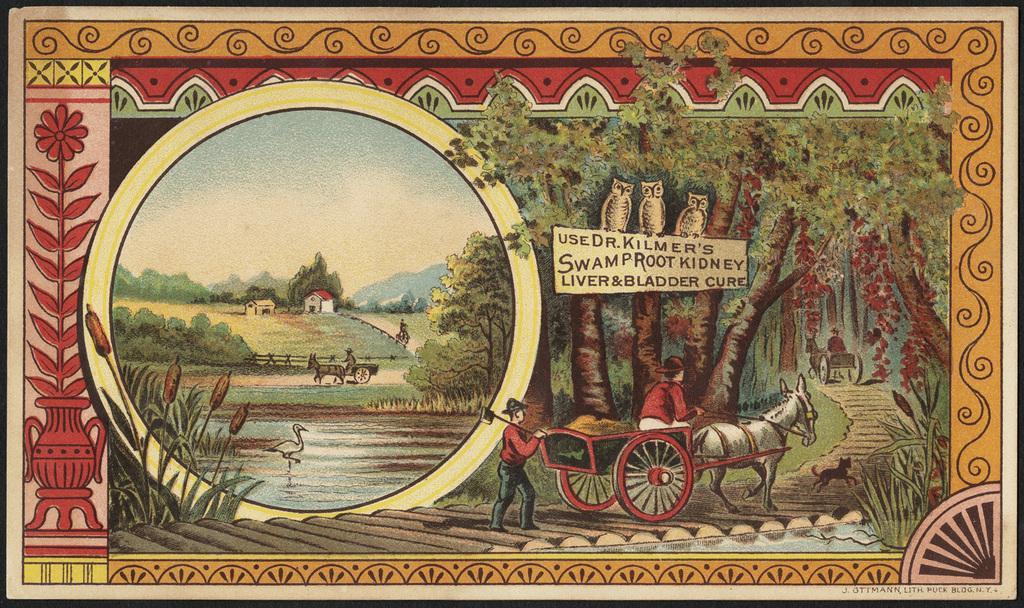Describe this image in one or two sentences. In the picture we can see a painting of a horse cart with a man sitting and riding it and behind it we can see a man walking holding a stick and in front of the cart we can see a dog running on the steps and beside it we can see another image with water and a bird in it and near to it we can see some plants, trees and behind it we can see some houses and in the background we can see hills and sky. 